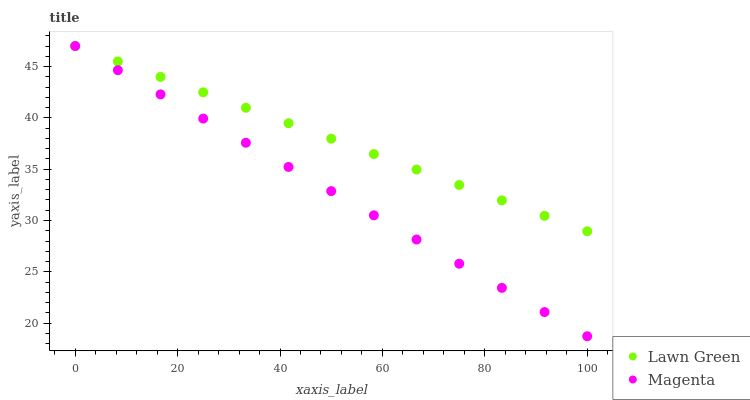Does Magenta have the minimum area under the curve?
Answer yes or no. Yes. Does Lawn Green have the maximum area under the curve?
Answer yes or no. Yes. Does Magenta have the maximum area under the curve?
Answer yes or no. No. Is Lawn Green the smoothest?
Answer yes or no. Yes. Is Magenta the roughest?
Answer yes or no. Yes. Is Magenta the smoothest?
Answer yes or no. No. Does Magenta have the lowest value?
Answer yes or no. Yes. Does Magenta have the highest value?
Answer yes or no. Yes. Does Lawn Green intersect Magenta?
Answer yes or no. Yes. Is Lawn Green less than Magenta?
Answer yes or no. No. Is Lawn Green greater than Magenta?
Answer yes or no. No. 